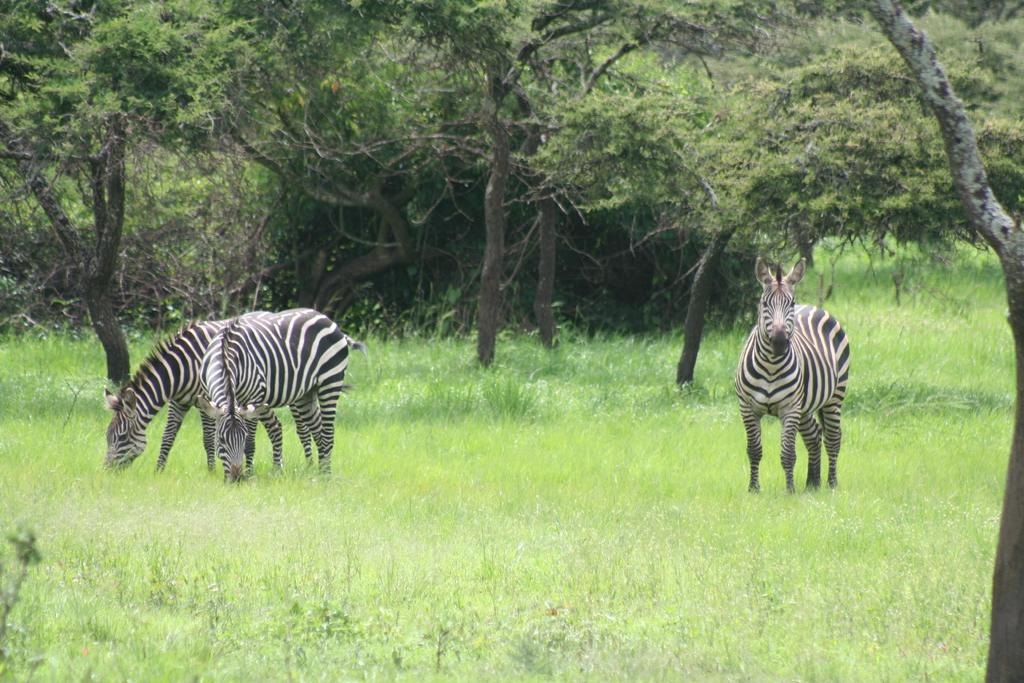What animals are present in the image? There are zebras in the image. What colors are the zebras? The zebras are in black and white color. What type of vegetation can be seen in the image? There are trees in the image. What is the color of the grass in the image? The grass is green in color. Can you see any goldfish swimming in the image? There are no goldfish present in the image; it features zebras, trees, and grass. 